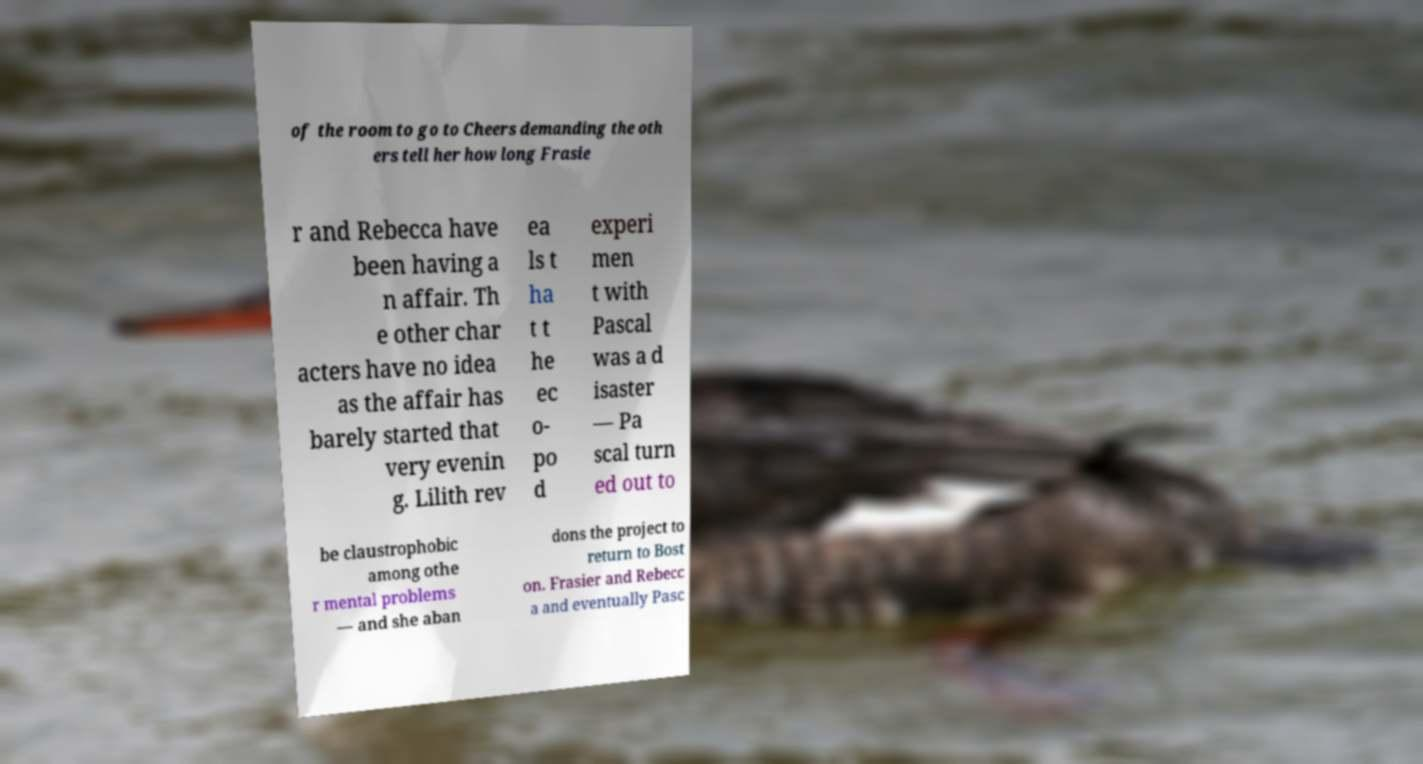Can you read and provide the text displayed in the image?This photo seems to have some interesting text. Can you extract and type it out for me? of the room to go to Cheers demanding the oth ers tell her how long Frasie r and Rebecca have been having a n affair. Th e other char acters have no idea as the affair has barely started that very evenin g. Lilith rev ea ls t ha t t he ec o- po d experi men t with Pascal was a d isaster — Pa scal turn ed out to be claustrophobic among othe r mental problems — and she aban dons the project to return to Bost on. Frasier and Rebecc a and eventually Pasc 